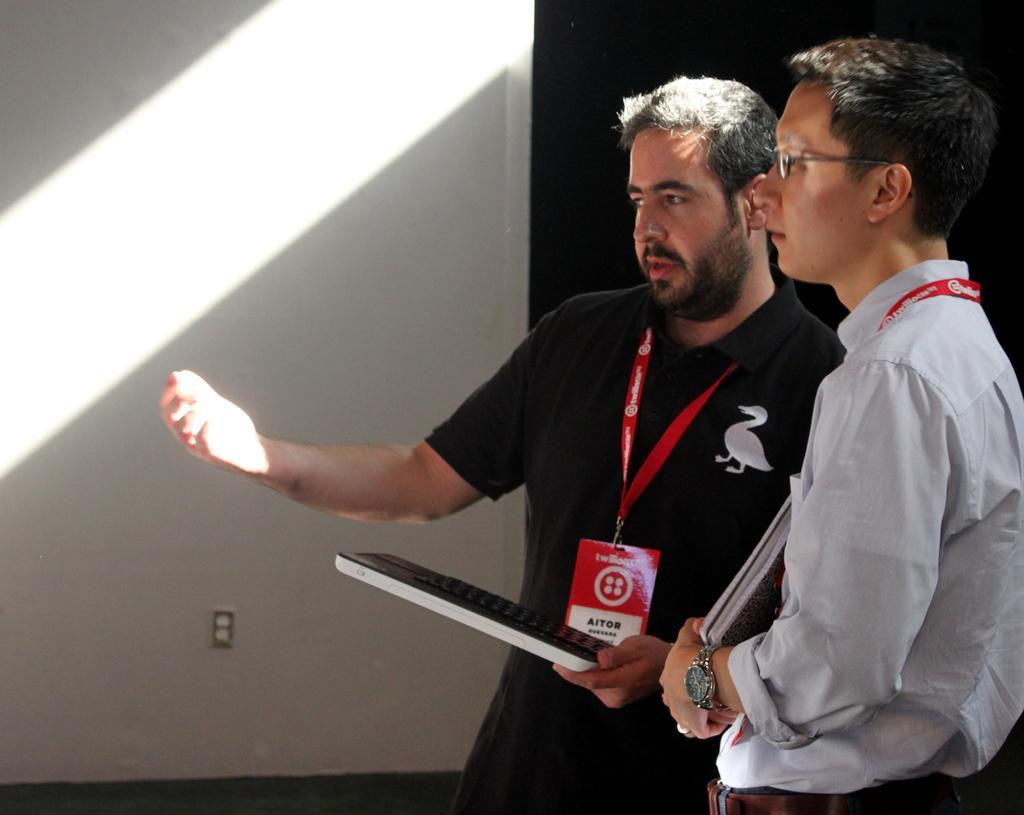Could you give a brief overview of what you see in this image? In this picture we can observe two men. Both of them are wearing red color tags in their necks. One of them is holding a laptop in his hands and he is wearing spectacles. In the background there is a wall. 